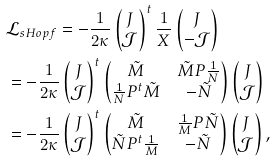<formula> <loc_0><loc_0><loc_500><loc_500>& \mathcal { L } _ { s H o p f } = - \frac { 1 } { 2 \kappa } \begin{pmatrix} J \\ \mathcal { J } \end{pmatrix} ^ { t } \frac { 1 } { X } \begin{pmatrix} J \\ - \mathcal { J } \end{pmatrix} \\ & = - \frac { 1 } { 2 \kappa } \begin{pmatrix} J \\ \mathcal { J } \end{pmatrix} ^ { t } \begin{pmatrix} \tilde { M } & \tilde { M } P \frac { 1 } { N } \\ \frac { 1 } { N } P ^ { t } \tilde { M } & - \tilde { N } \end{pmatrix} \begin{pmatrix} J \\ \mathcal { J } \end{pmatrix} \\ & = - \frac { 1 } { 2 \kappa } \begin{pmatrix} J \\ \mathcal { J } \end{pmatrix} ^ { t } \begin{pmatrix} \tilde { M } & \frac { 1 } { M } P \tilde { N } \\ \tilde { N } P ^ { t } \frac { 1 } { M } & - \tilde { N } \end{pmatrix} \begin{pmatrix} J \\ \mathcal { J } \end{pmatrix} ,</formula> 